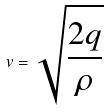<formula> <loc_0><loc_0><loc_500><loc_500>v = \sqrt { \frac { 2 q } { \rho } }</formula> 